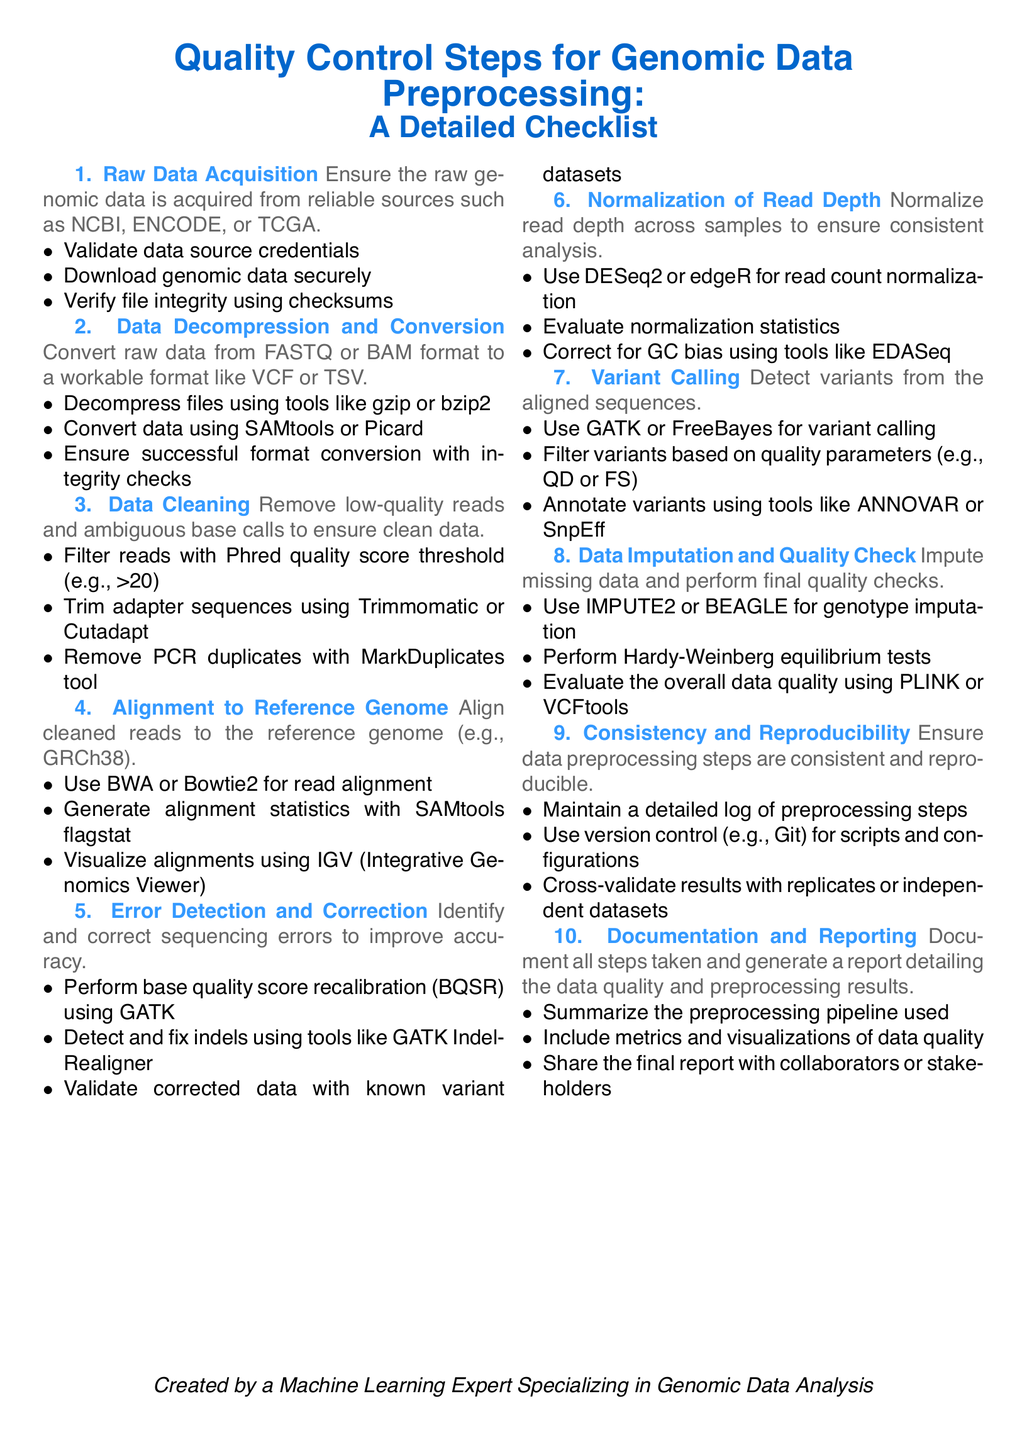What is the first step in the checklist? The first step is the initial action to ensure data quality before analysis. It is titled "Raw Data Acquisition."
Answer: Raw Data Acquisition How many steps are outlined in the document? The document presents a checklist with comprehensively defined actions spanning various areas. Counting the steps gives a total of ten.
Answer: 10 What tools are suggested for base quality score recalibration? The document highlights specific tools designed to improve data accuracy. The tool named for this action is indicated to be "GATK."
Answer: GATK Which step involves variant annotation? This step specifically addresses the detection and description of genetic variations in the data, which is titled "Variant Calling."
Answer: Variant Calling What is the purpose of using tools like DESeq2 or edgeR? These tools are mentioned in the context of adjusting data, specifically after the normalization process. They are used for normalizing read count.
Answer: Read count normalization What should be maintained to ensure reproducibility of data preprocessing? The importance of maintaining clarity and accountability in the research process is emphasized, specifically calling for a "detailed log of preprocessing steps."
Answer: Detailed log of preprocessing steps What is the main goal of the final checklist step? The last step focuses on ensuring that all actions taken are clearly documented and easily shared, which relates to "Documentation and Reporting."
Answer: Documentation and Reporting Which sequencing error correction tool is recommended? The specific tool recommended for addressing sequencing errors is noted in the checklist under "Error Detection and Correction." It is "GATK IndelRealigner."
Answer: GATK IndelRealigner What should the variant filter be based on? Variants in the data can be evaluated with respect to specific quality control metrics as highlighted, which include parameters like "QD or FS."
Answer: QD or FS 